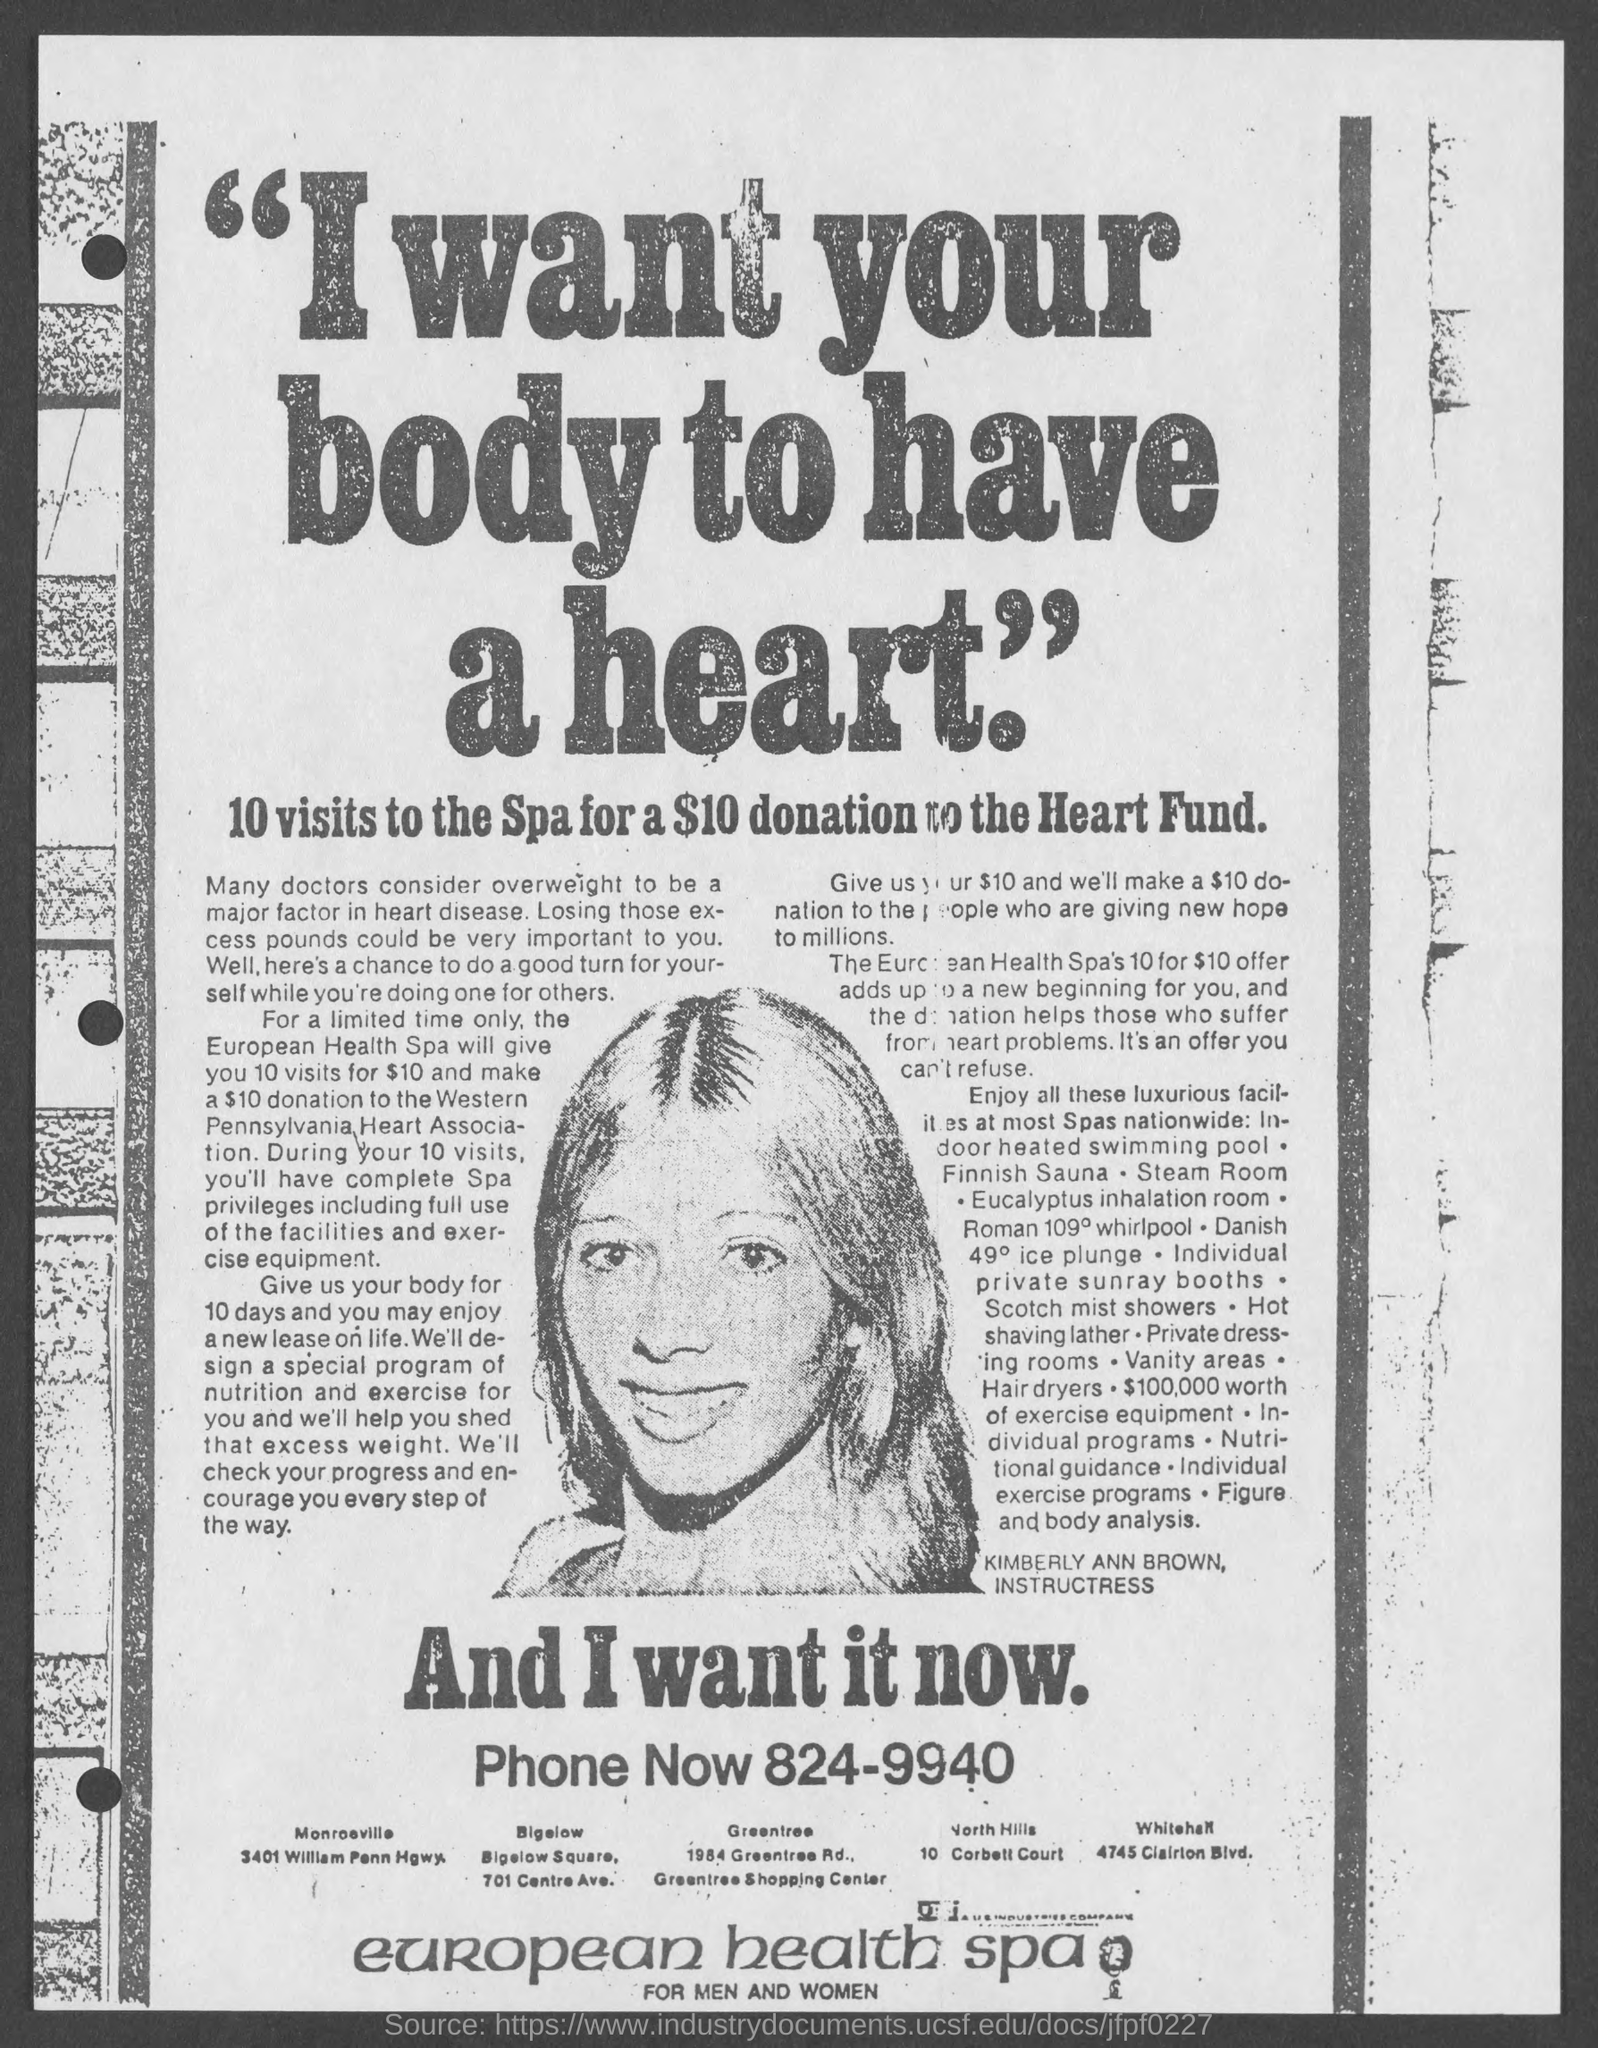10 visits to spa for how much donation?
Give a very brief answer. $10. What is the Phone?
Provide a succinct answer. 824-9940. 